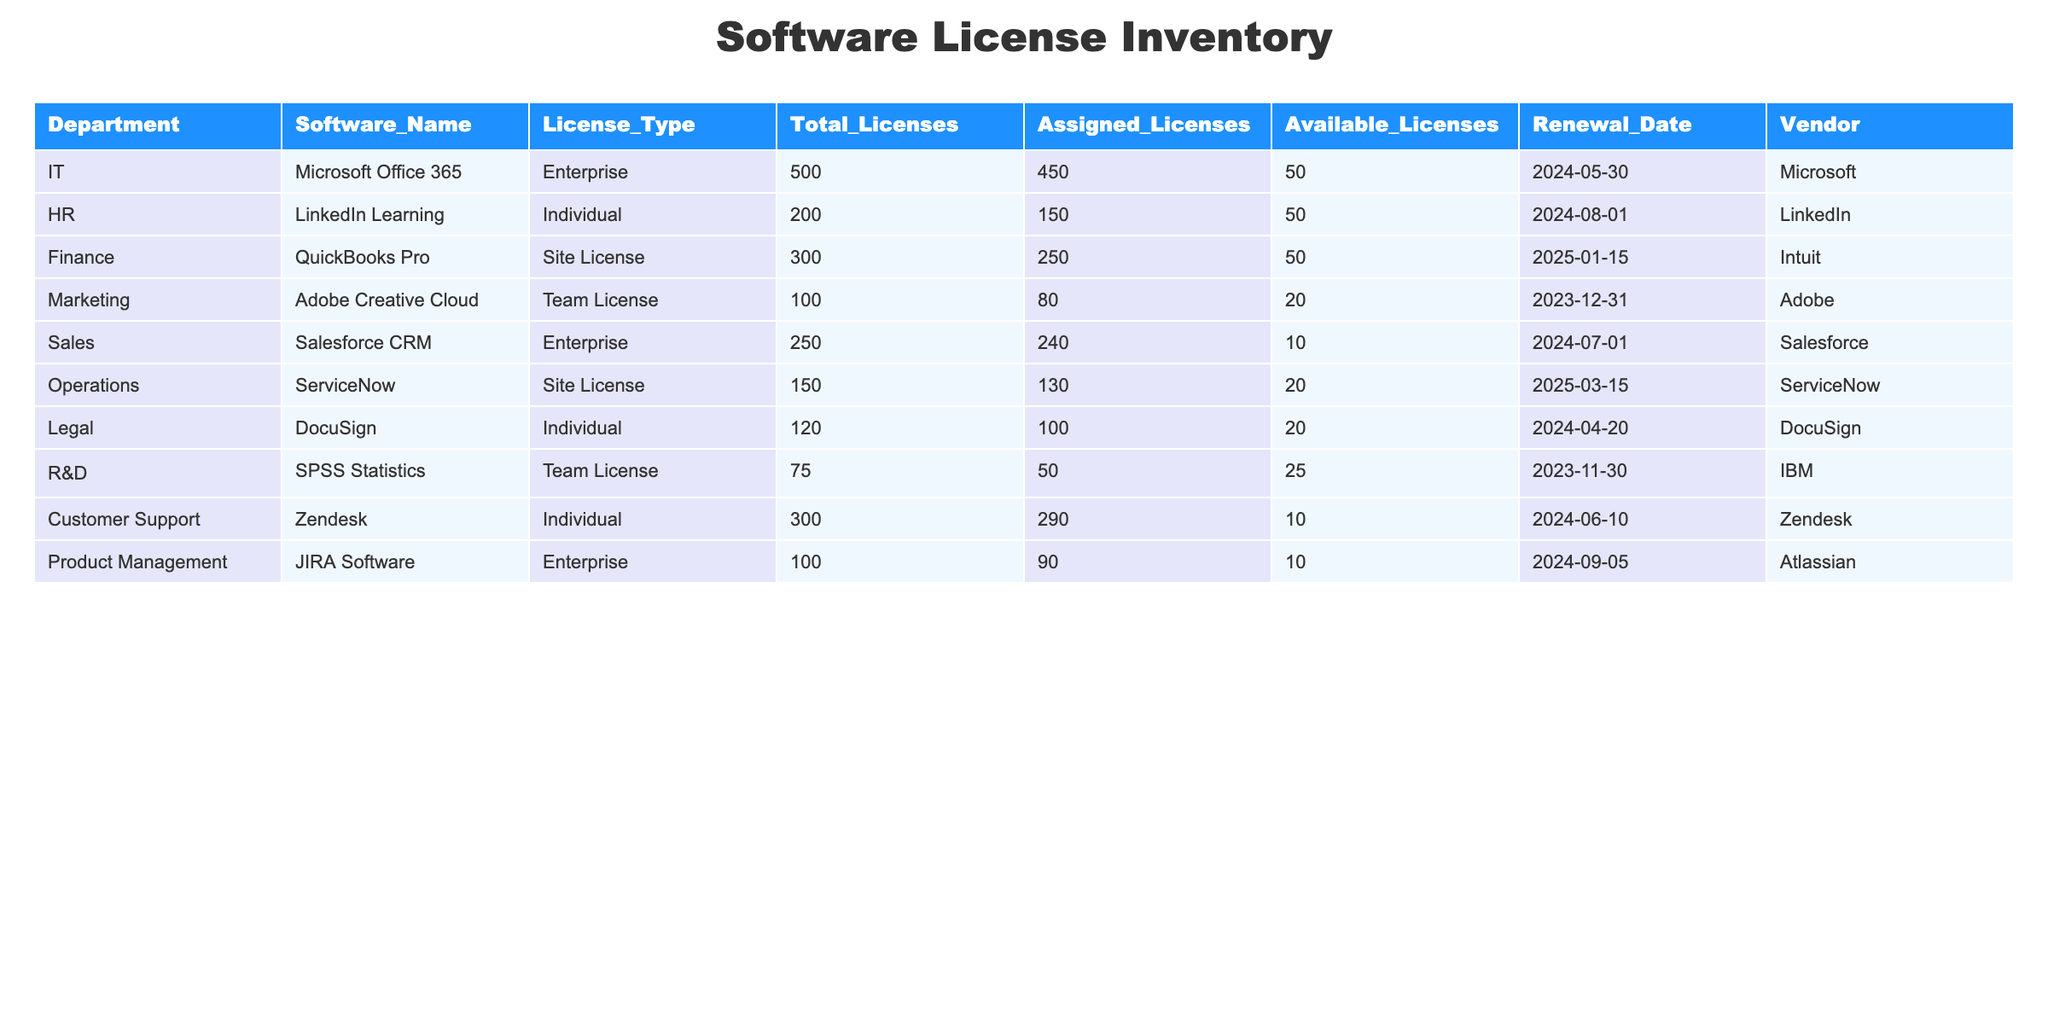What is the total number of licenses assigned to the Finance department? The table shows that the Finance department has a total of 300 licenses, out of which 250 licenses are assigned. Therefore, the total number of licenses assigned to the Finance department is 250.
Answer: 250 Which department has the most available licenses? By checking the available licenses for each department, we can see that IT has 50 licenses available, HR has 50 licenses, Finance has 50 licenses, Marketing has 20 licenses, Sales has 10 licenses, Operations has 20 licenses, Legal has 20 licenses, R&D has 25 licenses, Customer Support has 10 licenses, and Product Management has 10 licenses. The maximum available licenses, therefore, belong to IT, HR, and Finance, each with 50 licenses available.
Answer: IT, HR, Finance What is the percentage of total licenses that are assigned in the Sales department? The Sales department has a total of 250 licenses, of which 240 licenses are assigned. To calculate the percentage assigned, divide the number of assigned licenses by the total licenses and multiply by 100: (240/250) * 100 = 96%.
Answer: 96% Does the Marketing department have more assigned licenses than available licenses? The Marketing department has 80 assigned licenses and 20 available licenses. Since 80 is greater than 20, it confirms that the Marketing department has more assigned licenses than available licenses.
Answer: Yes What is the average number of available licenses across all departments? To find the average number of available licenses, first sum the available licenses: 50 (IT) + 50 (HR) + 50 (Finance) + 20 (Marketing) + 10 (Sales) + 20 (Operations) + 20 (Legal) + 25 (R&D) + 10 (Customer Support) + 10 (Product Management) = 275 available licenses. There are 10 departments, so the average is 275/10 = 27.5.
Answer: 27.5 